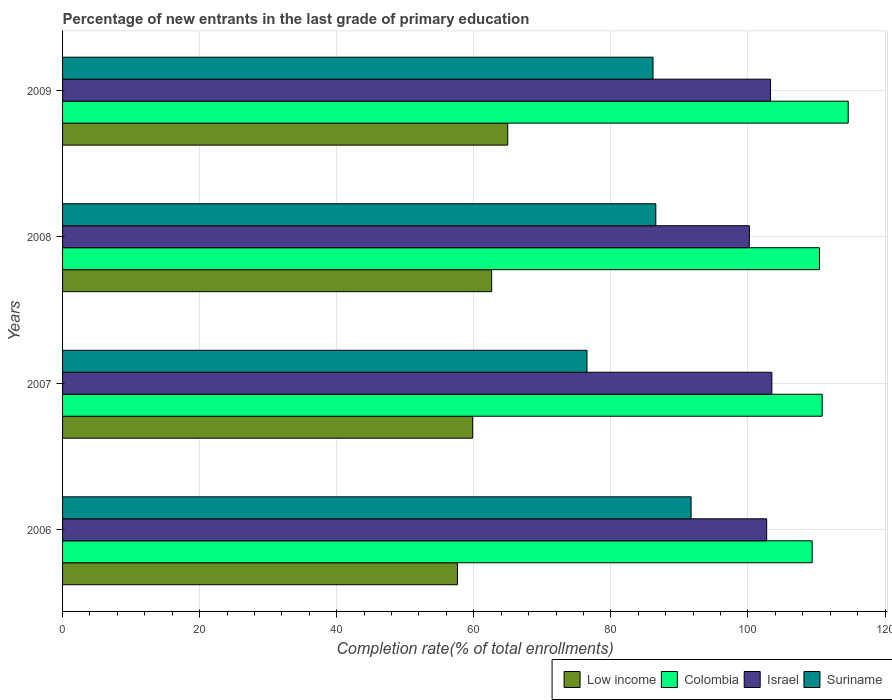How many different coloured bars are there?
Make the answer very short. 4. Are the number of bars per tick equal to the number of legend labels?
Keep it short and to the point. Yes. Are the number of bars on each tick of the Y-axis equal?
Your response must be concise. Yes. How many bars are there on the 1st tick from the top?
Provide a succinct answer. 4. What is the label of the 3rd group of bars from the top?
Provide a short and direct response. 2007. What is the percentage of new entrants in Colombia in 2006?
Your response must be concise. 109.36. Across all years, what is the maximum percentage of new entrants in Low income?
Offer a very short reply. 64.95. Across all years, what is the minimum percentage of new entrants in Suriname?
Keep it short and to the point. 76.51. In which year was the percentage of new entrants in Suriname maximum?
Your response must be concise. 2006. What is the total percentage of new entrants in Low income in the graph?
Make the answer very short. 245. What is the difference between the percentage of new entrants in Israel in 2007 and that in 2008?
Offer a terse response. 3.28. What is the difference between the percentage of new entrants in Colombia in 2008 and the percentage of new entrants in Suriname in 2007?
Provide a succinct answer. 33.92. What is the average percentage of new entrants in Low income per year?
Offer a terse response. 61.25. In the year 2008, what is the difference between the percentage of new entrants in Israel and percentage of new entrants in Colombia?
Your answer should be very brief. -10.22. What is the ratio of the percentage of new entrants in Suriname in 2008 to that in 2009?
Offer a terse response. 1. What is the difference between the highest and the second highest percentage of new entrants in Low income?
Your answer should be very brief. 2.35. What is the difference between the highest and the lowest percentage of new entrants in Colombia?
Ensure brevity in your answer.  5.26. Is it the case that in every year, the sum of the percentage of new entrants in Low income and percentage of new entrants in Suriname is greater than the sum of percentage of new entrants in Israel and percentage of new entrants in Colombia?
Make the answer very short. No. What does the 2nd bar from the top in 2008 represents?
Keep it short and to the point. Israel. What does the 4th bar from the bottom in 2007 represents?
Offer a terse response. Suriname. Is it the case that in every year, the sum of the percentage of new entrants in Suriname and percentage of new entrants in Colombia is greater than the percentage of new entrants in Low income?
Keep it short and to the point. Yes. Are all the bars in the graph horizontal?
Provide a short and direct response. Yes. How many years are there in the graph?
Your answer should be very brief. 4. Does the graph contain any zero values?
Give a very brief answer. No. Where does the legend appear in the graph?
Offer a very short reply. Bottom right. How are the legend labels stacked?
Your response must be concise. Horizontal. What is the title of the graph?
Offer a terse response. Percentage of new entrants in the last grade of primary education. Does "Curacao" appear as one of the legend labels in the graph?
Ensure brevity in your answer.  No. What is the label or title of the X-axis?
Offer a terse response. Completion rate(% of total enrollments). What is the Completion rate(% of total enrollments) in Low income in 2006?
Offer a terse response. 57.62. What is the Completion rate(% of total enrollments) in Colombia in 2006?
Offer a very short reply. 109.36. What is the Completion rate(% of total enrollments) in Israel in 2006?
Ensure brevity in your answer.  102.73. What is the Completion rate(% of total enrollments) of Suriname in 2006?
Provide a short and direct response. 91.7. What is the Completion rate(% of total enrollments) in Low income in 2007?
Offer a very short reply. 59.83. What is the Completion rate(% of total enrollments) in Colombia in 2007?
Your answer should be compact. 110.83. What is the Completion rate(% of total enrollments) of Israel in 2007?
Give a very brief answer. 103.49. What is the Completion rate(% of total enrollments) in Suriname in 2007?
Offer a very short reply. 76.51. What is the Completion rate(% of total enrollments) of Low income in 2008?
Offer a very short reply. 62.61. What is the Completion rate(% of total enrollments) of Colombia in 2008?
Keep it short and to the point. 110.43. What is the Completion rate(% of total enrollments) of Israel in 2008?
Give a very brief answer. 100.2. What is the Completion rate(% of total enrollments) of Suriname in 2008?
Your answer should be compact. 86.55. What is the Completion rate(% of total enrollments) in Low income in 2009?
Make the answer very short. 64.95. What is the Completion rate(% of total enrollments) in Colombia in 2009?
Ensure brevity in your answer.  114.62. What is the Completion rate(% of total enrollments) in Israel in 2009?
Offer a very short reply. 103.29. What is the Completion rate(% of total enrollments) in Suriname in 2009?
Keep it short and to the point. 86.15. Across all years, what is the maximum Completion rate(% of total enrollments) in Low income?
Provide a succinct answer. 64.95. Across all years, what is the maximum Completion rate(% of total enrollments) of Colombia?
Keep it short and to the point. 114.62. Across all years, what is the maximum Completion rate(% of total enrollments) in Israel?
Your answer should be very brief. 103.49. Across all years, what is the maximum Completion rate(% of total enrollments) of Suriname?
Keep it short and to the point. 91.7. Across all years, what is the minimum Completion rate(% of total enrollments) of Low income?
Offer a very short reply. 57.62. Across all years, what is the minimum Completion rate(% of total enrollments) of Colombia?
Offer a terse response. 109.36. Across all years, what is the minimum Completion rate(% of total enrollments) in Israel?
Keep it short and to the point. 100.2. Across all years, what is the minimum Completion rate(% of total enrollments) of Suriname?
Make the answer very short. 76.51. What is the total Completion rate(% of total enrollments) in Low income in the graph?
Ensure brevity in your answer.  245. What is the total Completion rate(% of total enrollments) in Colombia in the graph?
Your response must be concise. 445.24. What is the total Completion rate(% of total enrollments) in Israel in the graph?
Offer a very short reply. 409.71. What is the total Completion rate(% of total enrollments) in Suriname in the graph?
Offer a very short reply. 340.91. What is the difference between the Completion rate(% of total enrollments) of Low income in 2006 and that in 2007?
Keep it short and to the point. -2.22. What is the difference between the Completion rate(% of total enrollments) of Colombia in 2006 and that in 2007?
Provide a short and direct response. -1.46. What is the difference between the Completion rate(% of total enrollments) in Israel in 2006 and that in 2007?
Give a very brief answer. -0.76. What is the difference between the Completion rate(% of total enrollments) of Suriname in 2006 and that in 2007?
Offer a terse response. 15.19. What is the difference between the Completion rate(% of total enrollments) of Low income in 2006 and that in 2008?
Make the answer very short. -4.99. What is the difference between the Completion rate(% of total enrollments) of Colombia in 2006 and that in 2008?
Your answer should be very brief. -1.06. What is the difference between the Completion rate(% of total enrollments) of Israel in 2006 and that in 2008?
Make the answer very short. 2.52. What is the difference between the Completion rate(% of total enrollments) of Suriname in 2006 and that in 2008?
Offer a very short reply. 5.15. What is the difference between the Completion rate(% of total enrollments) in Low income in 2006 and that in 2009?
Make the answer very short. -7.34. What is the difference between the Completion rate(% of total enrollments) in Colombia in 2006 and that in 2009?
Give a very brief answer. -5.26. What is the difference between the Completion rate(% of total enrollments) in Israel in 2006 and that in 2009?
Offer a terse response. -0.57. What is the difference between the Completion rate(% of total enrollments) of Suriname in 2006 and that in 2009?
Your response must be concise. 5.55. What is the difference between the Completion rate(% of total enrollments) in Low income in 2007 and that in 2008?
Keep it short and to the point. -2.78. What is the difference between the Completion rate(% of total enrollments) of Colombia in 2007 and that in 2008?
Your response must be concise. 0.4. What is the difference between the Completion rate(% of total enrollments) of Israel in 2007 and that in 2008?
Ensure brevity in your answer.  3.28. What is the difference between the Completion rate(% of total enrollments) of Suriname in 2007 and that in 2008?
Offer a very short reply. -10.04. What is the difference between the Completion rate(% of total enrollments) in Low income in 2007 and that in 2009?
Your response must be concise. -5.12. What is the difference between the Completion rate(% of total enrollments) of Colombia in 2007 and that in 2009?
Keep it short and to the point. -3.8. What is the difference between the Completion rate(% of total enrollments) of Israel in 2007 and that in 2009?
Offer a very short reply. 0.19. What is the difference between the Completion rate(% of total enrollments) of Suriname in 2007 and that in 2009?
Give a very brief answer. -9.64. What is the difference between the Completion rate(% of total enrollments) of Low income in 2008 and that in 2009?
Offer a very short reply. -2.35. What is the difference between the Completion rate(% of total enrollments) of Colombia in 2008 and that in 2009?
Provide a succinct answer. -4.19. What is the difference between the Completion rate(% of total enrollments) in Israel in 2008 and that in 2009?
Provide a short and direct response. -3.09. What is the difference between the Completion rate(% of total enrollments) in Suriname in 2008 and that in 2009?
Provide a short and direct response. 0.41. What is the difference between the Completion rate(% of total enrollments) in Low income in 2006 and the Completion rate(% of total enrollments) in Colombia in 2007?
Your response must be concise. -53.21. What is the difference between the Completion rate(% of total enrollments) in Low income in 2006 and the Completion rate(% of total enrollments) in Israel in 2007?
Provide a short and direct response. -45.87. What is the difference between the Completion rate(% of total enrollments) of Low income in 2006 and the Completion rate(% of total enrollments) of Suriname in 2007?
Offer a terse response. -18.9. What is the difference between the Completion rate(% of total enrollments) of Colombia in 2006 and the Completion rate(% of total enrollments) of Israel in 2007?
Provide a short and direct response. 5.88. What is the difference between the Completion rate(% of total enrollments) of Colombia in 2006 and the Completion rate(% of total enrollments) of Suriname in 2007?
Offer a terse response. 32.85. What is the difference between the Completion rate(% of total enrollments) in Israel in 2006 and the Completion rate(% of total enrollments) in Suriname in 2007?
Your answer should be very brief. 26.21. What is the difference between the Completion rate(% of total enrollments) of Low income in 2006 and the Completion rate(% of total enrollments) of Colombia in 2008?
Give a very brief answer. -52.81. What is the difference between the Completion rate(% of total enrollments) of Low income in 2006 and the Completion rate(% of total enrollments) of Israel in 2008?
Keep it short and to the point. -42.59. What is the difference between the Completion rate(% of total enrollments) in Low income in 2006 and the Completion rate(% of total enrollments) in Suriname in 2008?
Make the answer very short. -28.94. What is the difference between the Completion rate(% of total enrollments) in Colombia in 2006 and the Completion rate(% of total enrollments) in Israel in 2008?
Ensure brevity in your answer.  9.16. What is the difference between the Completion rate(% of total enrollments) of Colombia in 2006 and the Completion rate(% of total enrollments) of Suriname in 2008?
Offer a terse response. 22.81. What is the difference between the Completion rate(% of total enrollments) in Israel in 2006 and the Completion rate(% of total enrollments) in Suriname in 2008?
Ensure brevity in your answer.  16.17. What is the difference between the Completion rate(% of total enrollments) of Low income in 2006 and the Completion rate(% of total enrollments) of Colombia in 2009?
Provide a succinct answer. -57.01. What is the difference between the Completion rate(% of total enrollments) of Low income in 2006 and the Completion rate(% of total enrollments) of Israel in 2009?
Provide a succinct answer. -45.68. What is the difference between the Completion rate(% of total enrollments) of Low income in 2006 and the Completion rate(% of total enrollments) of Suriname in 2009?
Offer a very short reply. -28.53. What is the difference between the Completion rate(% of total enrollments) of Colombia in 2006 and the Completion rate(% of total enrollments) of Israel in 2009?
Offer a very short reply. 6.07. What is the difference between the Completion rate(% of total enrollments) of Colombia in 2006 and the Completion rate(% of total enrollments) of Suriname in 2009?
Keep it short and to the point. 23.22. What is the difference between the Completion rate(% of total enrollments) of Israel in 2006 and the Completion rate(% of total enrollments) of Suriname in 2009?
Offer a terse response. 16.58. What is the difference between the Completion rate(% of total enrollments) of Low income in 2007 and the Completion rate(% of total enrollments) of Colombia in 2008?
Keep it short and to the point. -50.6. What is the difference between the Completion rate(% of total enrollments) of Low income in 2007 and the Completion rate(% of total enrollments) of Israel in 2008?
Your answer should be very brief. -40.37. What is the difference between the Completion rate(% of total enrollments) of Low income in 2007 and the Completion rate(% of total enrollments) of Suriname in 2008?
Your response must be concise. -26.72. What is the difference between the Completion rate(% of total enrollments) of Colombia in 2007 and the Completion rate(% of total enrollments) of Israel in 2008?
Offer a very short reply. 10.62. What is the difference between the Completion rate(% of total enrollments) of Colombia in 2007 and the Completion rate(% of total enrollments) of Suriname in 2008?
Ensure brevity in your answer.  24.27. What is the difference between the Completion rate(% of total enrollments) in Israel in 2007 and the Completion rate(% of total enrollments) in Suriname in 2008?
Make the answer very short. 16.93. What is the difference between the Completion rate(% of total enrollments) in Low income in 2007 and the Completion rate(% of total enrollments) in Colombia in 2009?
Ensure brevity in your answer.  -54.79. What is the difference between the Completion rate(% of total enrollments) in Low income in 2007 and the Completion rate(% of total enrollments) in Israel in 2009?
Your answer should be compact. -43.46. What is the difference between the Completion rate(% of total enrollments) in Low income in 2007 and the Completion rate(% of total enrollments) in Suriname in 2009?
Your answer should be compact. -26.32. What is the difference between the Completion rate(% of total enrollments) in Colombia in 2007 and the Completion rate(% of total enrollments) in Israel in 2009?
Make the answer very short. 7.54. What is the difference between the Completion rate(% of total enrollments) in Colombia in 2007 and the Completion rate(% of total enrollments) in Suriname in 2009?
Provide a short and direct response. 24.68. What is the difference between the Completion rate(% of total enrollments) in Israel in 2007 and the Completion rate(% of total enrollments) in Suriname in 2009?
Provide a short and direct response. 17.34. What is the difference between the Completion rate(% of total enrollments) in Low income in 2008 and the Completion rate(% of total enrollments) in Colombia in 2009?
Provide a short and direct response. -52.02. What is the difference between the Completion rate(% of total enrollments) of Low income in 2008 and the Completion rate(% of total enrollments) of Israel in 2009?
Your response must be concise. -40.69. What is the difference between the Completion rate(% of total enrollments) of Low income in 2008 and the Completion rate(% of total enrollments) of Suriname in 2009?
Offer a very short reply. -23.54. What is the difference between the Completion rate(% of total enrollments) in Colombia in 2008 and the Completion rate(% of total enrollments) in Israel in 2009?
Your response must be concise. 7.14. What is the difference between the Completion rate(% of total enrollments) of Colombia in 2008 and the Completion rate(% of total enrollments) of Suriname in 2009?
Your response must be concise. 24.28. What is the difference between the Completion rate(% of total enrollments) in Israel in 2008 and the Completion rate(% of total enrollments) in Suriname in 2009?
Provide a short and direct response. 14.06. What is the average Completion rate(% of total enrollments) of Low income per year?
Give a very brief answer. 61.25. What is the average Completion rate(% of total enrollments) in Colombia per year?
Ensure brevity in your answer.  111.31. What is the average Completion rate(% of total enrollments) in Israel per year?
Provide a short and direct response. 102.43. What is the average Completion rate(% of total enrollments) in Suriname per year?
Ensure brevity in your answer.  85.23. In the year 2006, what is the difference between the Completion rate(% of total enrollments) of Low income and Completion rate(% of total enrollments) of Colombia?
Ensure brevity in your answer.  -51.75. In the year 2006, what is the difference between the Completion rate(% of total enrollments) of Low income and Completion rate(% of total enrollments) of Israel?
Offer a very short reply. -45.11. In the year 2006, what is the difference between the Completion rate(% of total enrollments) in Low income and Completion rate(% of total enrollments) in Suriname?
Provide a succinct answer. -34.08. In the year 2006, what is the difference between the Completion rate(% of total enrollments) of Colombia and Completion rate(% of total enrollments) of Israel?
Make the answer very short. 6.64. In the year 2006, what is the difference between the Completion rate(% of total enrollments) in Colombia and Completion rate(% of total enrollments) in Suriname?
Ensure brevity in your answer.  17.67. In the year 2006, what is the difference between the Completion rate(% of total enrollments) in Israel and Completion rate(% of total enrollments) in Suriname?
Make the answer very short. 11.03. In the year 2007, what is the difference between the Completion rate(% of total enrollments) of Low income and Completion rate(% of total enrollments) of Colombia?
Make the answer very short. -51. In the year 2007, what is the difference between the Completion rate(% of total enrollments) of Low income and Completion rate(% of total enrollments) of Israel?
Offer a terse response. -43.66. In the year 2007, what is the difference between the Completion rate(% of total enrollments) of Low income and Completion rate(% of total enrollments) of Suriname?
Provide a succinct answer. -16.68. In the year 2007, what is the difference between the Completion rate(% of total enrollments) of Colombia and Completion rate(% of total enrollments) of Israel?
Keep it short and to the point. 7.34. In the year 2007, what is the difference between the Completion rate(% of total enrollments) of Colombia and Completion rate(% of total enrollments) of Suriname?
Give a very brief answer. 34.32. In the year 2007, what is the difference between the Completion rate(% of total enrollments) in Israel and Completion rate(% of total enrollments) in Suriname?
Your answer should be compact. 26.97. In the year 2008, what is the difference between the Completion rate(% of total enrollments) of Low income and Completion rate(% of total enrollments) of Colombia?
Your response must be concise. -47.82. In the year 2008, what is the difference between the Completion rate(% of total enrollments) of Low income and Completion rate(% of total enrollments) of Israel?
Offer a terse response. -37.6. In the year 2008, what is the difference between the Completion rate(% of total enrollments) in Low income and Completion rate(% of total enrollments) in Suriname?
Ensure brevity in your answer.  -23.95. In the year 2008, what is the difference between the Completion rate(% of total enrollments) in Colombia and Completion rate(% of total enrollments) in Israel?
Offer a very short reply. 10.22. In the year 2008, what is the difference between the Completion rate(% of total enrollments) of Colombia and Completion rate(% of total enrollments) of Suriname?
Provide a succinct answer. 23.88. In the year 2008, what is the difference between the Completion rate(% of total enrollments) of Israel and Completion rate(% of total enrollments) of Suriname?
Provide a short and direct response. 13.65. In the year 2009, what is the difference between the Completion rate(% of total enrollments) of Low income and Completion rate(% of total enrollments) of Colombia?
Your response must be concise. -49.67. In the year 2009, what is the difference between the Completion rate(% of total enrollments) of Low income and Completion rate(% of total enrollments) of Israel?
Keep it short and to the point. -38.34. In the year 2009, what is the difference between the Completion rate(% of total enrollments) in Low income and Completion rate(% of total enrollments) in Suriname?
Keep it short and to the point. -21.19. In the year 2009, what is the difference between the Completion rate(% of total enrollments) of Colombia and Completion rate(% of total enrollments) of Israel?
Your answer should be compact. 11.33. In the year 2009, what is the difference between the Completion rate(% of total enrollments) of Colombia and Completion rate(% of total enrollments) of Suriname?
Offer a terse response. 28.48. In the year 2009, what is the difference between the Completion rate(% of total enrollments) in Israel and Completion rate(% of total enrollments) in Suriname?
Your answer should be compact. 17.15. What is the ratio of the Completion rate(% of total enrollments) of Colombia in 2006 to that in 2007?
Make the answer very short. 0.99. What is the ratio of the Completion rate(% of total enrollments) of Israel in 2006 to that in 2007?
Ensure brevity in your answer.  0.99. What is the ratio of the Completion rate(% of total enrollments) of Suriname in 2006 to that in 2007?
Your answer should be compact. 1.2. What is the ratio of the Completion rate(% of total enrollments) in Low income in 2006 to that in 2008?
Offer a terse response. 0.92. What is the ratio of the Completion rate(% of total enrollments) in Israel in 2006 to that in 2008?
Ensure brevity in your answer.  1.03. What is the ratio of the Completion rate(% of total enrollments) of Suriname in 2006 to that in 2008?
Give a very brief answer. 1.06. What is the ratio of the Completion rate(% of total enrollments) of Low income in 2006 to that in 2009?
Give a very brief answer. 0.89. What is the ratio of the Completion rate(% of total enrollments) in Colombia in 2006 to that in 2009?
Your answer should be very brief. 0.95. What is the ratio of the Completion rate(% of total enrollments) in Israel in 2006 to that in 2009?
Your answer should be compact. 0.99. What is the ratio of the Completion rate(% of total enrollments) in Suriname in 2006 to that in 2009?
Keep it short and to the point. 1.06. What is the ratio of the Completion rate(% of total enrollments) of Low income in 2007 to that in 2008?
Your answer should be very brief. 0.96. What is the ratio of the Completion rate(% of total enrollments) of Israel in 2007 to that in 2008?
Offer a terse response. 1.03. What is the ratio of the Completion rate(% of total enrollments) in Suriname in 2007 to that in 2008?
Make the answer very short. 0.88. What is the ratio of the Completion rate(% of total enrollments) in Low income in 2007 to that in 2009?
Provide a succinct answer. 0.92. What is the ratio of the Completion rate(% of total enrollments) in Colombia in 2007 to that in 2009?
Your response must be concise. 0.97. What is the ratio of the Completion rate(% of total enrollments) of Israel in 2007 to that in 2009?
Ensure brevity in your answer.  1. What is the ratio of the Completion rate(% of total enrollments) of Suriname in 2007 to that in 2009?
Keep it short and to the point. 0.89. What is the ratio of the Completion rate(% of total enrollments) of Low income in 2008 to that in 2009?
Offer a terse response. 0.96. What is the ratio of the Completion rate(% of total enrollments) of Colombia in 2008 to that in 2009?
Provide a succinct answer. 0.96. What is the ratio of the Completion rate(% of total enrollments) of Israel in 2008 to that in 2009?
Offer a terse response. 0.97. What is the ratio of the Completion rate(% of total enrollments) in Suriname in 2008 to that in 2009?
Your response must be concise. 1. What is the difference between the highest and the second highest Completion rate(% of total enrollments) in Low income?
Provide a short and direct response. 2.35. What is the difference between the highest and the second highest Completion rate(% of total enrollments) of Colombia?
Keep it short and to the point. 3.8. What is the difference between the highest and the second highest Completion rate(% of total enrollments) in Israel?
Provide a short and direct response. 0.19. What is the difference between the highest and the second highest Completion rate(% of total enrollments) of Suriname?
Your answer should be very brief. 5.15. What is the difference between the highest and the lowest Completion rate(% of total enrollments) of Low income?
Offer a terse response. 7.34. What is the difference between the highest and the lowest Completion rate(% of total enrollments) of Colombia?
Your answer should be very brief. 5.26. What is the difference between the highest and the lowest Completion rate(% of total enrollments) in Israel?
Offer a very short reply. 3.28. What is the difference between the highest and the lowest Completion rate(% of total enrollments) in Suriname?
Provide a succinct answer. 15.19. 